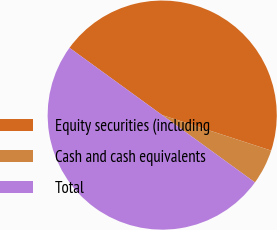Convert chart. <chart><loc_0><loc_0><loc_500><loc_500><pie_chart><fcel>Equity securities (including<fcel>Cash and cash equivalents<fcel>Total<nl><fcel>45.02%<fcel>4.98%<fcel>50.0%<nl></chart> 